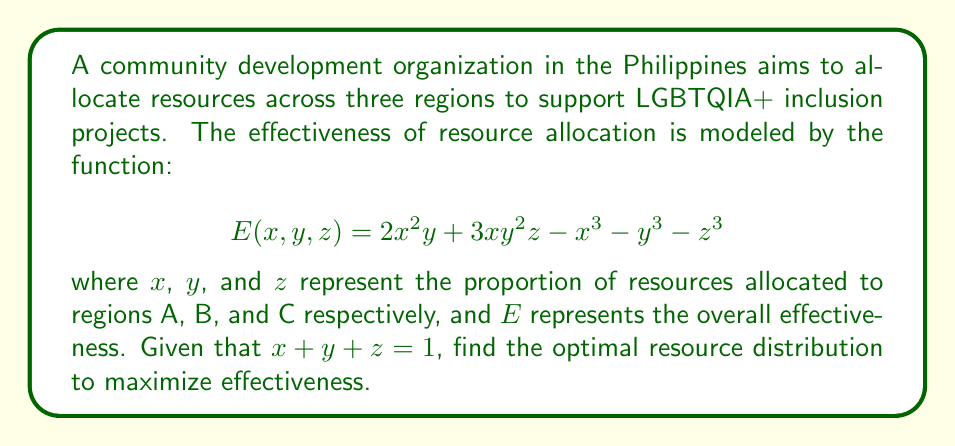Provide a solution to this math problem. To find the optimal resource distribution, we need to maximize $E(x,y,z)$ subject to the constraint $x + y + z = 1$. We can use the method of Lagrange multipliers:

1) Form the Lagrangian function:
   $$L(x,y,z,\lambda) = 2x^2y + 3xy^2z - x^3 - y^3 - z^3 - \lambda(x + y + z - 1)$$

2) Calculate partial derivatives and set them to zero:
   $$\frac{\partial L}{\partial x} = 4xy + 3y^2z - 3x^2 - \lambda = 0$$
   $$\frac{\partial L}{\partial y} = 2x^2 + 6xyz - 3y^2 - \lambda = 0$$
   $$\frac{\partial L}{\partial z} = 3xy^2 - 3z^2 - \lambda = 0$$
   $$\frac{\partial L}{\partial \lambda} = x + y + z - 1 = 0$$

3) From the symmetry of these equations and the constraint, we can deduce that the optimal solution likely has $x = y = z$.

4) Substituting this into the constraint equation:
   $$x + x + x = 1$$
   $$3x = 1$$
   $$x = \frac{1}{3}$$

5) Therefore, $x = y = z = \frac{1}{3}$

6) To confirm this is a maximum, we would need to check the second derivatives, but given the context of the problem, this solution makes sense.
Answer: $x = y = z = \frac{1}{3}$ 